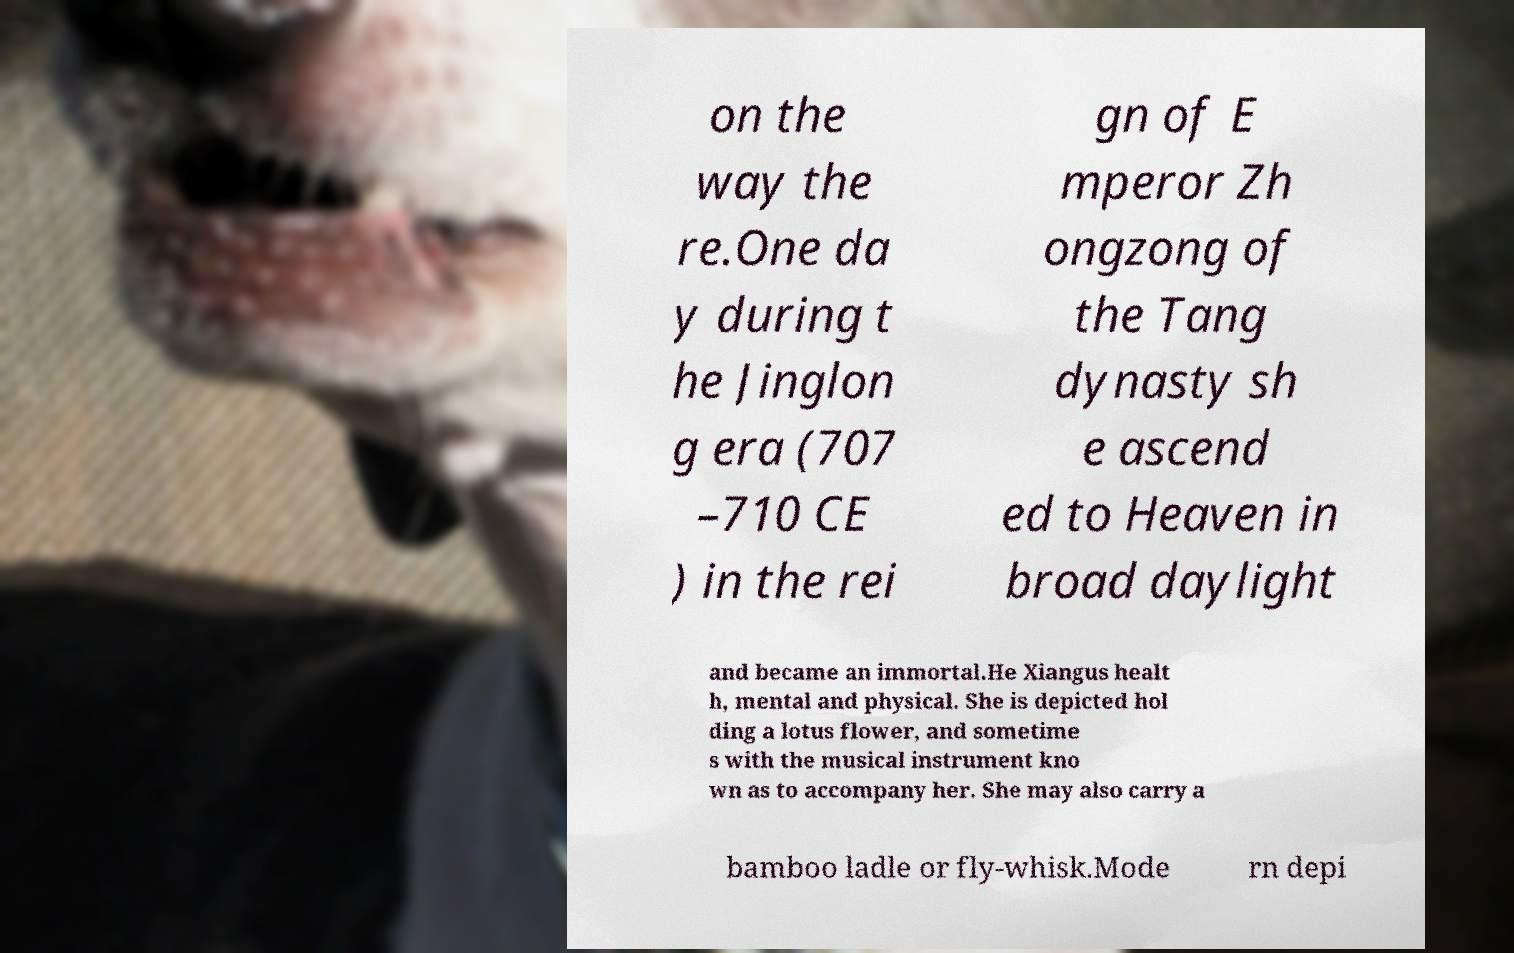Can you accurately transcribe the text from the provided image for me? on the way the re.One da y during t he Jinglon g era (707 –710 CE ) in the rei gn of E mperor Zh ongzong of the Tang dynasty sh e ascend ed to Heaven in broad daylight and became an immortal.He Xiangus healt h, mental and physical. She is depicted hol ding a lotus flower, and sometime s with the musical instrument kno wn as to accompany her. She may also carry a bamboo ladle or fly-whisk.Mode rn depi 